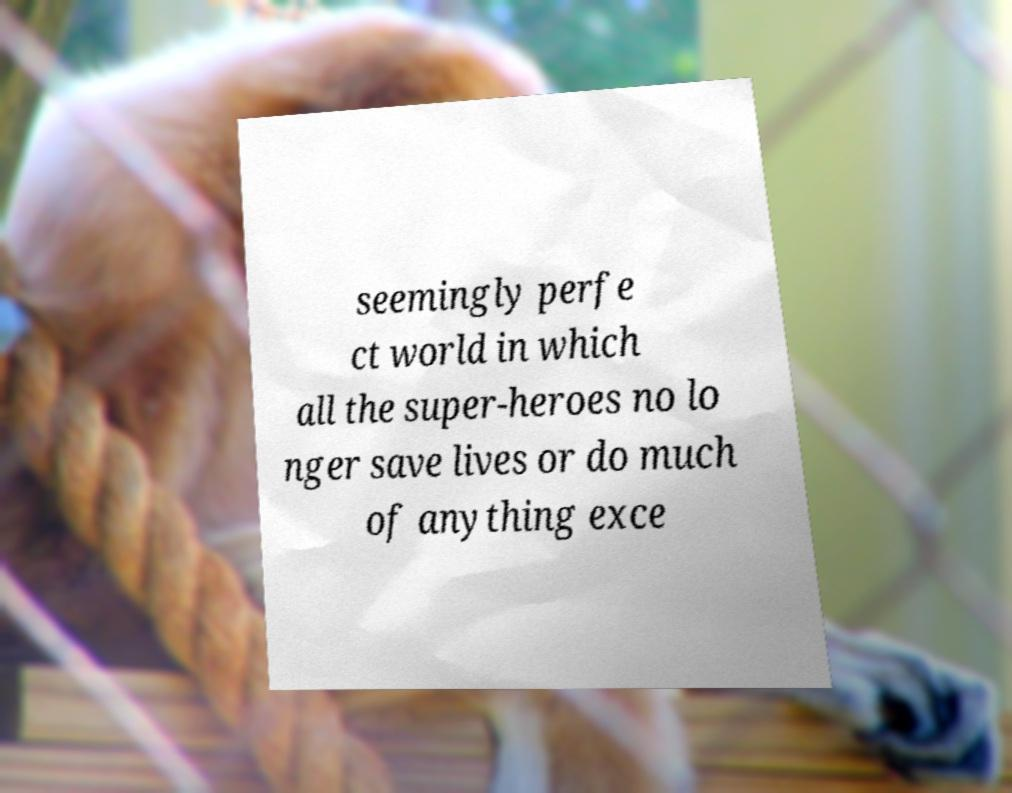Could you assist in decoding the text presented in this image and type it out clearly? seemingly perfe ct world in which all the super-heroes no lo nger save lives or do much of anything exce 